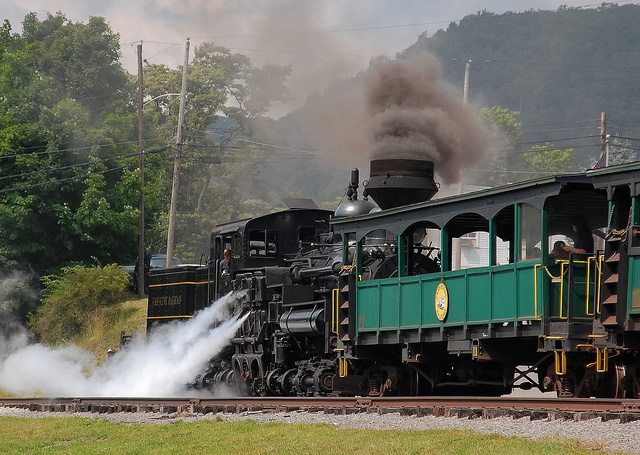Describe the objects in this image and their specific colors. I can see train in darkgray, black, gray, and teal tones, people in darkgray, black, brown, and maroon tones, people in darkgray, black, and gray tones, people in darkgray, black, gray, and maroon tones, and people in darkgray, gray, teal, and black tones in this image. 